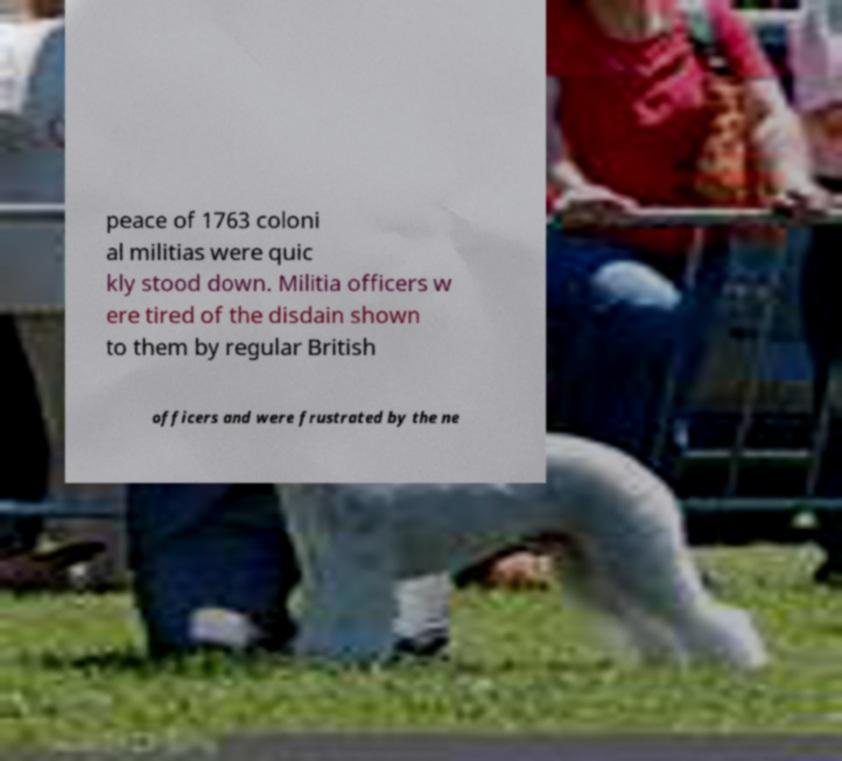Could you extract and type out the text from this image? peace of 1763 coloni al militias were quic kly stood down. Militia officers w ere tired of the disdain shown to them by regular British officers and were frustrated by the ne 